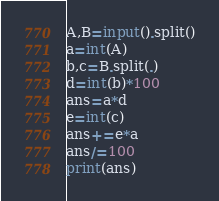Convert code to text. <code><loc_0><loc_0><loc_500><loc_500><_Python_>A,B=input().split()
a=int(A)
b,c=B.split(.)
d=int(b)*100
ans=a*d
e=int(c)
ans+=e*a
ans/=100
print(ans)
</code> 